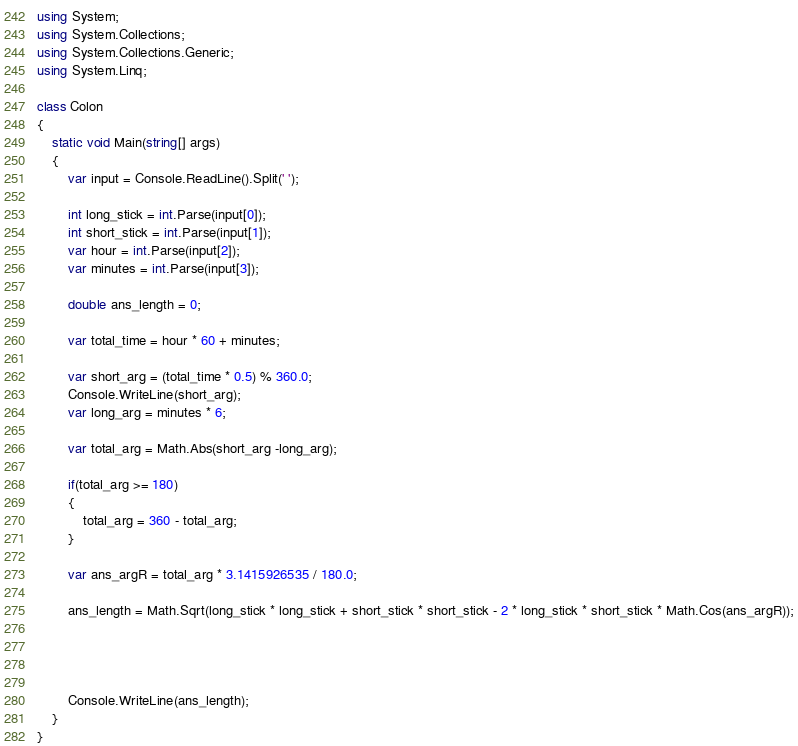<code> <loc_0><loc_0><loc_500><loc_500><_C#_>using System;
using System.Collections;
using System.Collections.Generic;
using System.Linq;

class Colon
{
    static void Main(string[] args)
    {
        var input = Console.ReadLine().Split(' ');

        int long_stick = int.Parse(input[0]);
        int short_stick = int.Parse(input[1]);
        var hour = int.Parse(input[2]);
        var minutes = int.Parse(input[3]);

        double ans_length = 0;

        var total_time = hour * 60 + minutes;

        var short_arg = (total_time * 0.5) % 360.0;
        Console.WriteLine(short_arg);
        var long_arg = minutes * 6;

        var total_arg = Math.Abs(short_arg -long_arg);

        if(total_arg >= 180)
        {
            total_arg = 360 - total_arg;
        }

        var ans_argR = total_arg * 3.1415926535 / 180.0; 

        ans_length = Math.Sqrt(long_stick * long_stick + short_stick * short_stick - 2 * long_stick * short_stick * Math.Cos(ans_argR));




        Console.WriteLine(ans_length);
    }
}</code> 